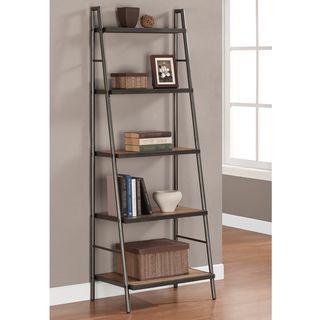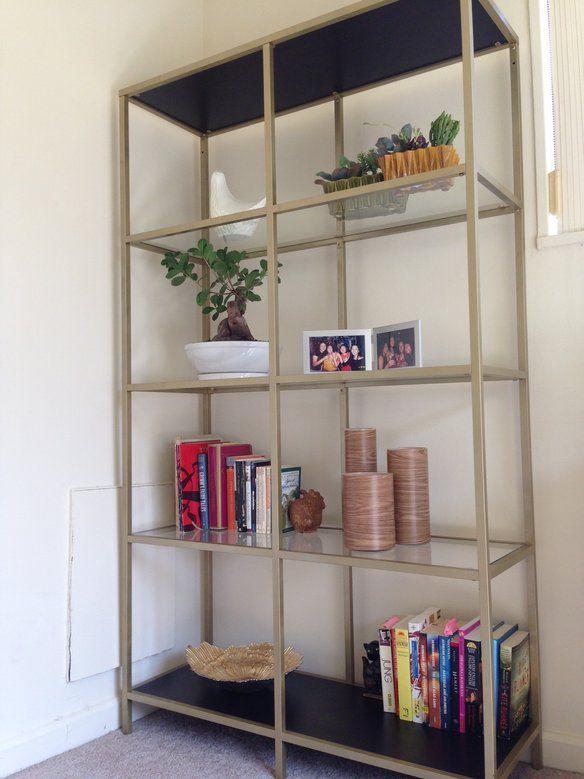The first image is the image on the left, the second image is the image on the right. Considering the images on both sides, is "In the image on the left, the shelves are placed in a corner." valid? Answer yes or no. No. The first image is the image on the left, the second image is the image on the right. For the images displayed, is the sentence "One image shows a shelf unit with open back and sides that resembles a ladder leaning on a wall, and it is not positioned in a corner." factually correct? Answer yes or no. Yes. 